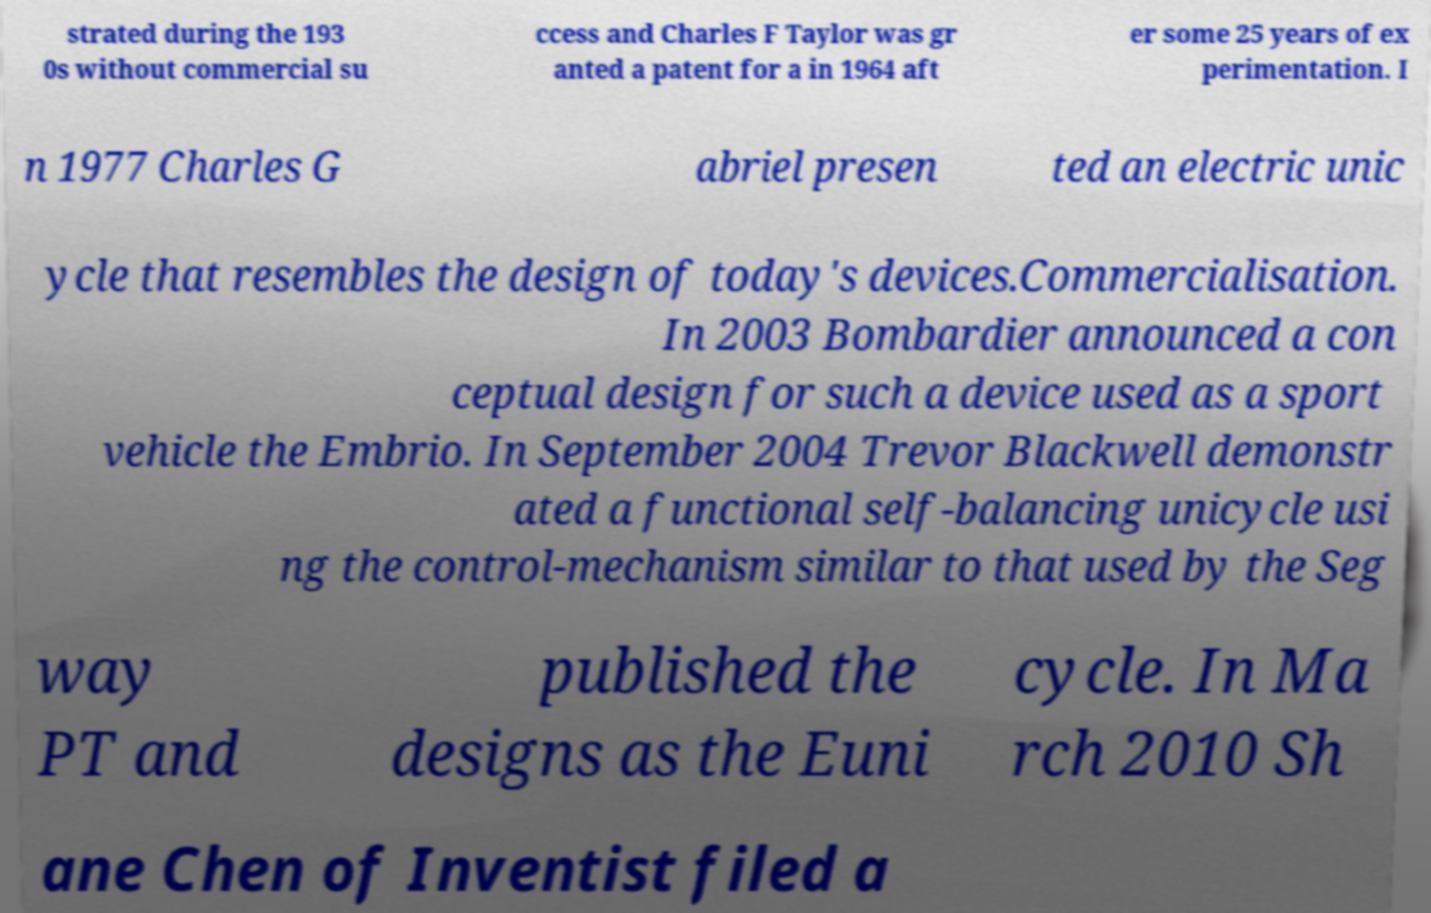For documentation purposes, I need the text within this image transcribed. Could you provide that? strated during the 193 0s without commercial su ccess and Charles F Taylor was gr anted a patent for a in 1964 aft er some 25 years of ex perimentation. I n 1977 Charles G abriel presen ted an electric unic ycle that resembles the design of today's devices.Commercialisation. In 2003 Bombardier announced a con ceptual design for such a device used as a sport vehicle the Embrio. In September 2004 Trevor Blackwell demonstr ated a functional self-balancing unicycle usi ng the control-mechanism similar to that used by the Seg way PT and published the designs as the Euni cycle. In Ma rch 2010 Sh ane Chen of Inventist filed a 